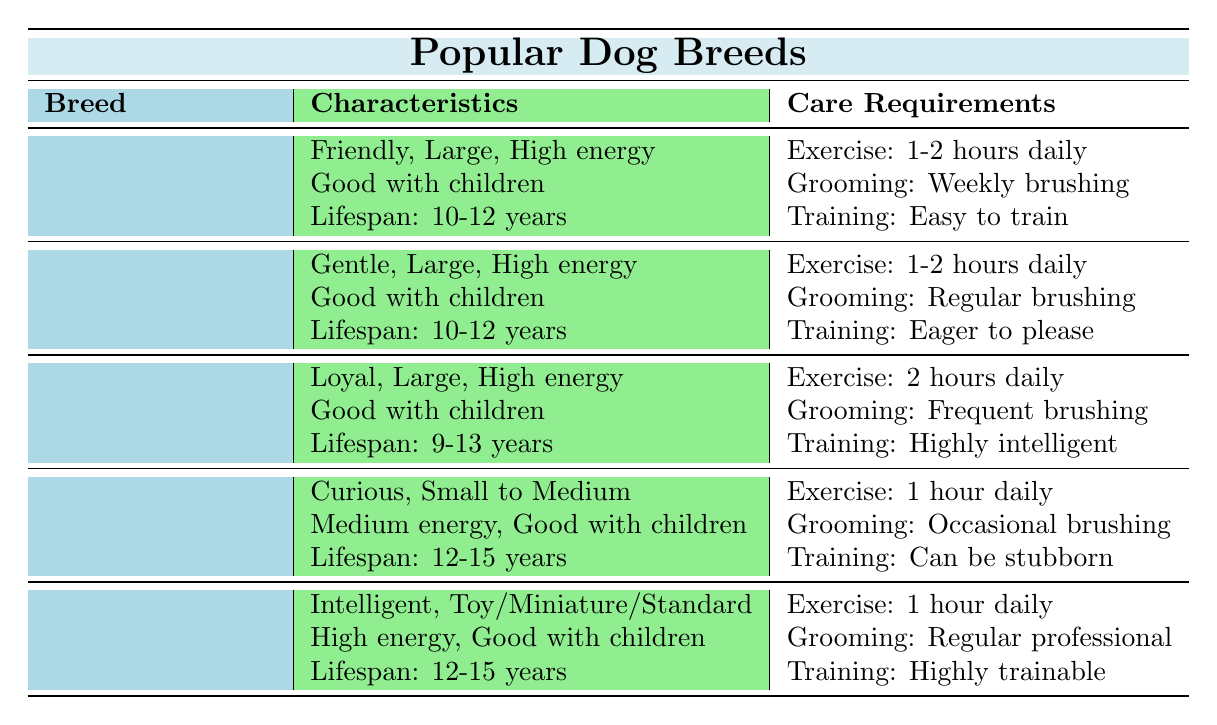What is the energy level of a Beagle? The table lists Beagle under the characteristics, where it mentions the energy level as "Medium."
Answer: Medium How long is the lifespan of a Golden Retriever? The table provides the lifespan of Golden Retrievers as "10-12 years."
Answer: 10-12 years Is a Poodle good with children? The characteristics for Poodles indicate that they are "Good with Children," so the answer is yes.
Answer: Yes Which breed has the highest exercise requirement? Checking the exercise requirements, the German Shepherd requires "2 hours daily," which is more than any other breed listed.
Answer: German Shepherd How many breeds have a lifespan of 12-15 years? Both the Beagle and Poodle have a lifespan of 12-15 years. Therefore, there are two breeds that meet this criterion.
Answer: 2 What is the grooming requirement for a Labrador Retriever? The grooming requirement listed for Labrador Retrievers is "Weekly brushing."
Answer: Weekly brushing Which breed is described as having a strong trainability? Both German Shepherds and Poodles are described as having high trainability; the German Shepherd is "Highly intelligent," and the Poodle is "Highly trainable."
Answer: German Shepherd and Poodle What is the range of lifespan for a German Shepherd compared to a Labrador Retriever? A German Shepherd's lifespan ranges from "9-13 years," while a Labrador Retriever's lifespan is "10-12 years." Comparing both, the German Shepherd has a wider range but generally can live longer.
Answer: 9-13 years vs. 10-12 years Which dog breeds are listed as good with children? The table indicates that all the breeds listed (Labrador Retriever, Golden Retriever, German Shepherd, Beagle, and Poodle) are good with children.
Answer: All breeds (Labrador, Golden, German Shepherd, Beagle, Poodle) What is the predominant size category for the Labrador Retriever and the Golden Retriever? Both breeds are classified as "Large" in size.
Answer: Large How does the exercise requirement of a Poodle compare to that of a Beagle? The Poodle requires "1 hour daily" while the Beagle requires "1 hour daily." Thus, their exercise requirements are the same.
Answer: Same (1 hour daily) 